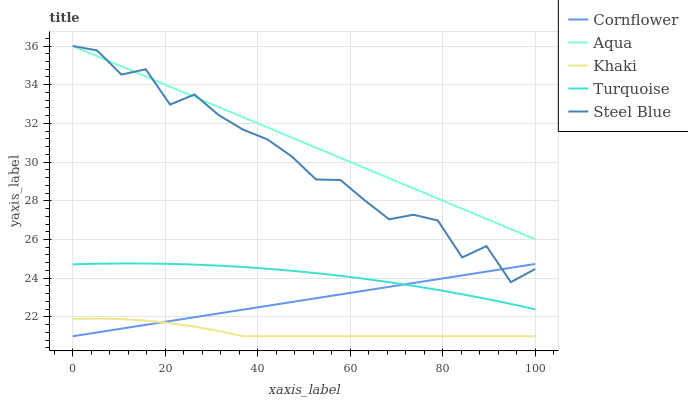Does Khaki have the minimum area under the curve?
Answer yes or no. Yes. Does Aqua have the maximum area under the curve?
Answer yes or no. Yes. Does Turquoise have the minimum area under the curve?
Answer yes or no. No. Does Turquoise have the maximum area under the curve?
Answer yes or no. No. Is Aqua the smoothest?
Answer yes or no. Yes. Is Steel Blue the roughest?
Answer yes or no. Yes. Is Turquoise the smoothest?
Answer yes or no. No. Is Turquoise the roughest?
Answer yes or no. No. Does Turquoise have the lowest value?
Answer yes or no. No. Does Steel Blue have the highest value?
Answer yes or no. Yes. Does Turquoise have the highest value?
Answer yes or no. No. Is Cornflower less than Aqua?
Answer yes or no. Yes. Is Aqua greater than Cornflower?
Answer yes or no. Yes. Does Steel Blue intersect Aqua?
Answer yes or no. Yes. Is Steel Blue less than Aqua?
Answer yes or no. No. Is Steel Blue greater than Aqua?
Answer yes or no. No. Does Cornflower intersect Aqua?
Answer yes or no. No. 